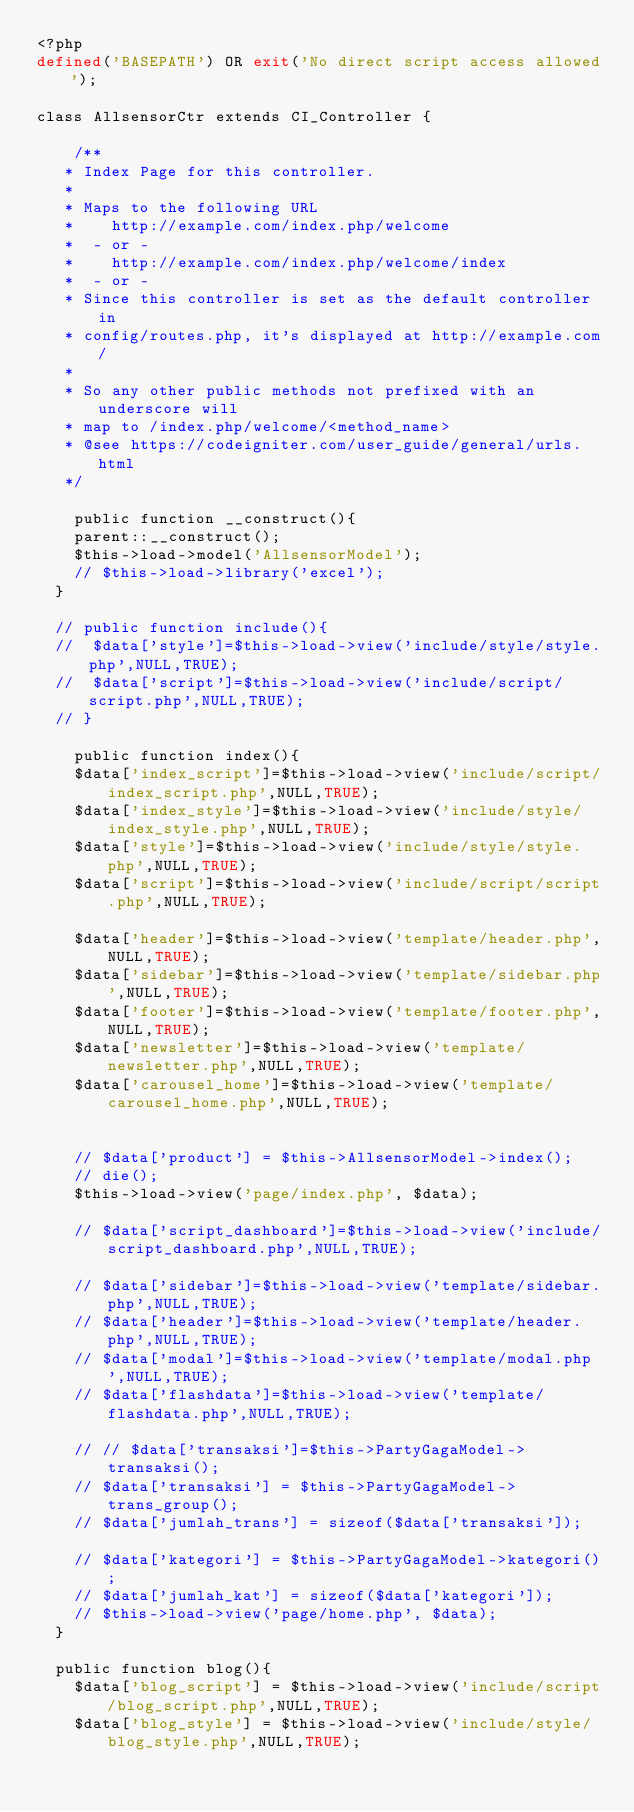Convert code to text. <code><loc_0><loc_0><loc_500><loc_500><_PHP_><?php
defined('BASEPATH') OR exit('No direct script access allowed');

class AllsensorCtr extends CI_Controller {

    /** 
	 * Index Page for this controller.
	 *
	 * Maps to the following URL
	 * 		http://example.com/index.php/welcome
	 *	- or -
	 * 		http://example.com/index.php/welcome/index
	 *	- or -
	 * Since this controller is set as the default controller in
	 * config/routes.php, it's displayed at http://example.com/
	 *
	 * So any other public methods not prefixed with an underscore will
	 * map to /index.php/welcome/<method_name>
	 * @see https://codeigniter.com/user_guide/general/urls.html
	 */

    public function __construct(){
		parent::__construct();
		$this->load->model('AllsensorModel');
		// $this->load->library('excel');
	}
	
	// public function include(){
	// 	$data['style']=$this->load->view('include/style/style.php',NULL,TRUE);
	// 	$data['script']=$this->load->view('include/script/script.php',NULL,TRUE);
	// }
    
    public function index(){
		$data['index_script']=$this->load->view('include/script/index_script.php',NULL,TRUE);
		$data['index_style']=$this->load->view('include/style/index_style.php',NULL,TRUE);
		$data['style']=$this->load->view('include/style/style.php',NULL,TRUE);
		$data['script']=$this->load->view('include/script/script.php',NULL,TRUE);

		$data['header']=$this->load->view('template/header.php',NULL,TRUE);
		$data['sidebar']=$this->load->view('template/sidebar.php',NULL,TRUE);
		$data['footer']=$this->load->view('template/footer.php',NULL,TRUE);
		$data['newsletter']=$this->load->view('template/newsletter.php',NULL,TRUE);
		$data['carousel_home']=$this->load->view('template/carousel_home.php',NULL,TRUE);
		

		// $data['product'] = $this->AllsensorModel->index();
		// die();
		$this->load->view('page/index.php', $data);

		// $data['script_dashboard']=$this->load->view('include/script_dashboard.php',NULL,TRUE);
		
		// $data['sidebar']=$this->load->view('template/sidebar.php',NULL,TRUE);
		// $data['header']=$this->load->view('template/header.php',NULL,TRUE);
		// $data['modal']=$this->load->view('template/modal.php',NULL,TRUE);
		// $data['flashdata']=$this->load->view('template/flashdata.php',NULL,TRUE);

		// // $data['transaksi']=$this->PartyGagaModel->transaksi();
		// $data['transaksi'] = $this->PartyGagaModel->trans_group();
		// $data['jumlah_trans'] = sizeof($data['transaksi']);

		// $data['kategori'] = $this->PartyGagaModel->kategori();
		// $data['jumlah_kat'] = sizeof($data['kategori']);
		// $this->load->view('page/home.php', $data);
	}
	
	public function blog(){
		$data['blog_script'] = $this->load->view('include/script/blog_script.php',NULL,TRUE);
		$data['blog_style'] = $this->load->view('include/style/blog_style.php',NULL,TRUE);</code> 